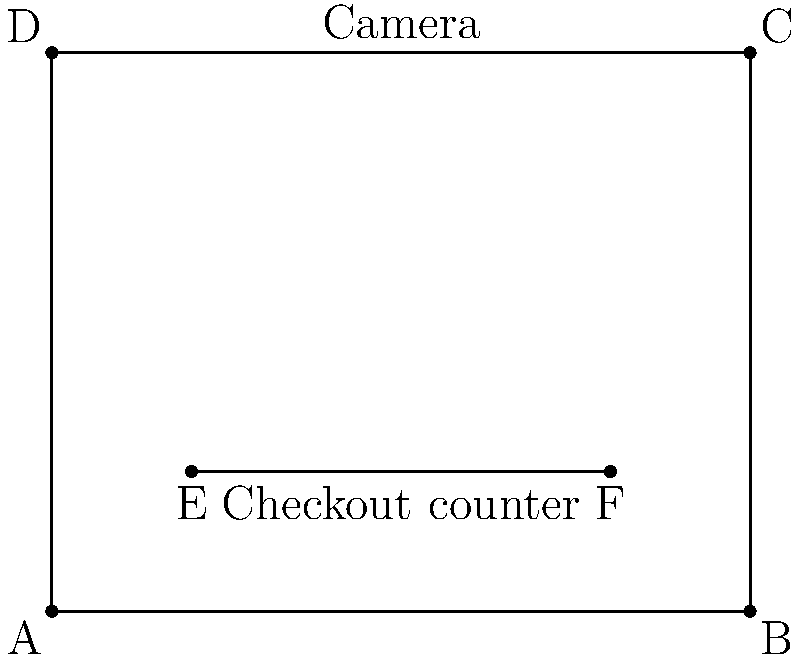In your retail store, you want to implement facial recognition technology for improved security and customer experience. The store layout is rectangular, measuring 10 meters wide and 8 meters deep. A camera for facial recognition will be mounted at the center of the back wall. You plan to install a straight checkout counter parallel to the front wall. If the optimal viewing angle for facial recognition is 60°, how far from the front wall should the checkout counter be placed to ensure the entire length of the counter is within the camera's optimal viewing angle? Let's approach this step-by-step:

1) First, we need to understand that the camera's field of view forms an isosceles triangle with a 60° angle at the top.

2) The camera is mounted at the center of the back wall, which is 8 meters from the front wall.

3) We need to find the distance from the front wall where the checkout counter should be placed. Let's call this distance $x$.

4) The half-angle of the camera's field of view is 30° (half of 60°).

5) In a right triangle formed by half of the camera's field of view:
   - The adjacent side is $(8-x)$ meters (distance from counter to back wall)
   - The opposite side is 5 meters (half the width of the store)

6) We can use the tangent function:

   $$\tan(30°) = \frac{\text{opposite}}{\text{adjacent}} = \frac{5}{8-x}$$

7) We know that $\tan(30°) = \frac{1}{\sqrt{3}}$, so:

   $$\frac{1}{\sqrt{3}} = \frac{5}{8-x}$$

8) Cross multiply:

   $$\sqrt{3}(8-x) = 5$$

9) Solve for $x$:
   
   $$8\sqrt{3} - x\sqrt{3} = 5$$
   $$x\sqrt{3} = 8\sqrt{3} - 5$$
   $$x = 8 - \frac{5}{\sqrt{3}} \approx 5.11$$

Therefore, the checkout counter should be placed approximately 5.11 meters from the front wall.
Answer: 5.11 meters 